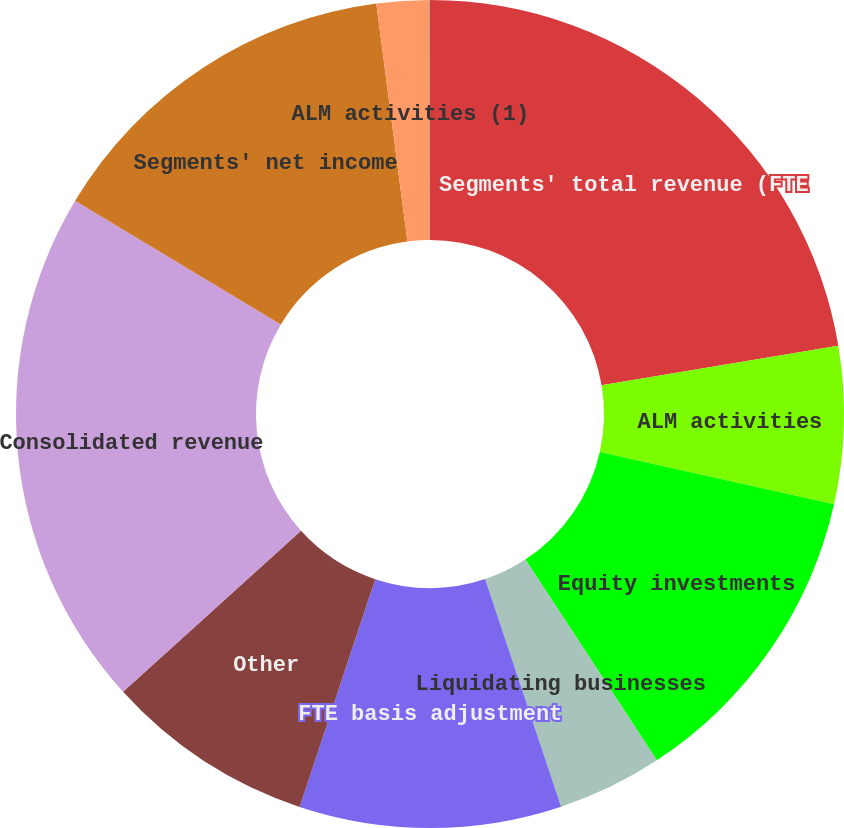<chart> <loc_0><loc_0><loc_500><loc_500><pie_chart><fcel>Segments' total revenue (FTE<fcel>ALM activities<fcel>Equity investments<fcel>Liquidating businesses<fcel>FTE basis adjustment<fcel>Other<fcel>Consolidated revenue<fcel>Segments' net income<fcel>ALM activities (1)<fcel>Litigation expense<nl><fcel>22.36%<fcel>6.14%<fcel>12.27%<fcel>4.1%<fcel>10.23%<fcel>8.19%<fcel>20.32%<fcel>14.32%<fcel>2.06%<fcel>0.01%<nl></chart> 